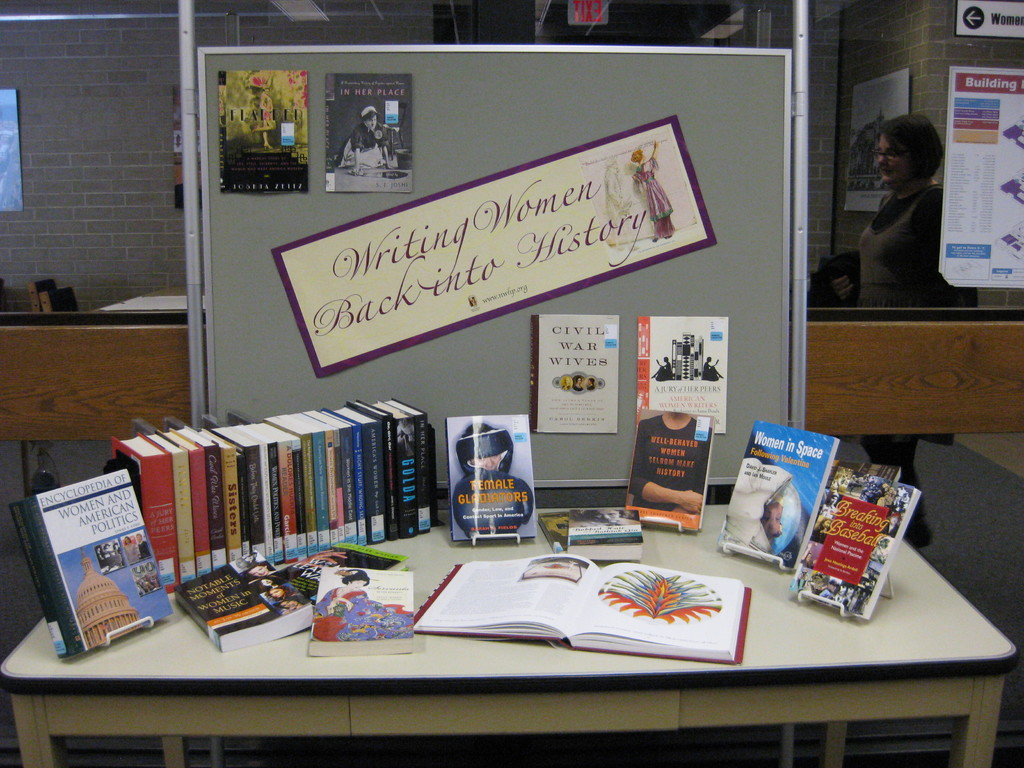Provide a one-sentence caption for the provided image. The photograph shows a curated exhibition of diverse books themed around 'Writing Women Back into History,' featuring topics from women in politics to notable women in the civil war, strategically placed under a purple and gold banner. 